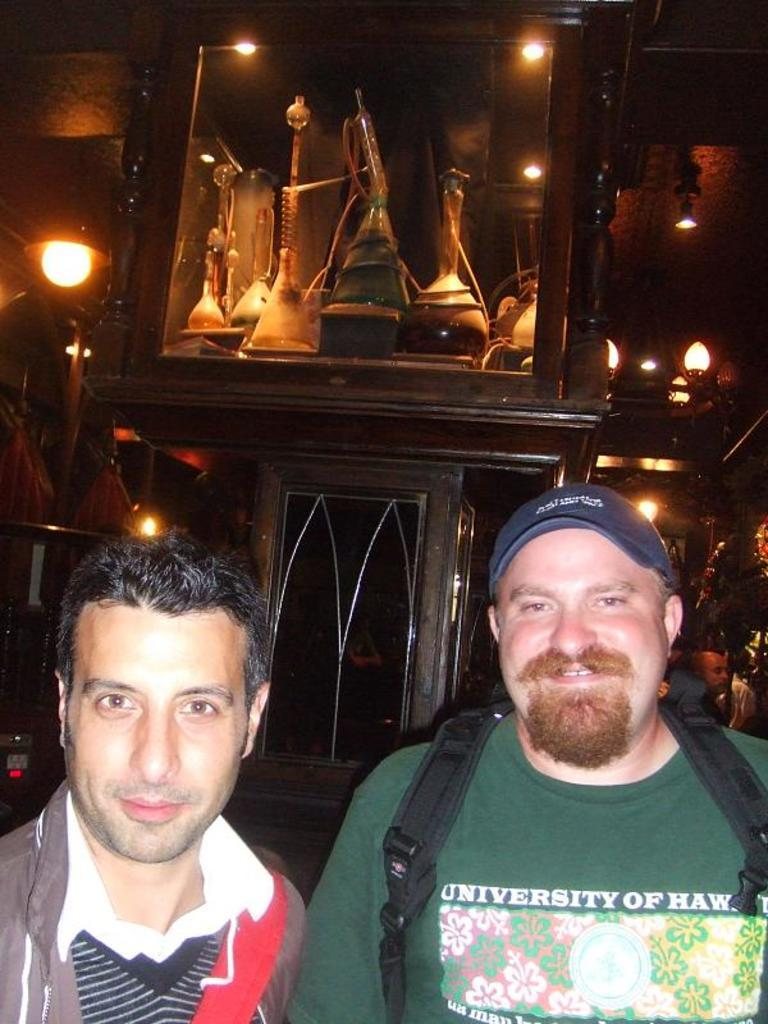How many people are in the image? There are two men in the image. What is one of the men wearing? One of the men is wearing a green T-shirt. What can be seen in the background of the image? There is a box in the background of the image. What is inside the box? The box contains hookah pots. What can be seen in the image that provides illumination? There are lights visible in the image. How many tickets does the man in the green T-shirt have in his possession? There is no mention of tickets in the image, so it cannot be determined how many the man in the green T-shirt has. What type of debt is being discussed by the two men in the image? There is no indication of a discussion about debt in the image. 